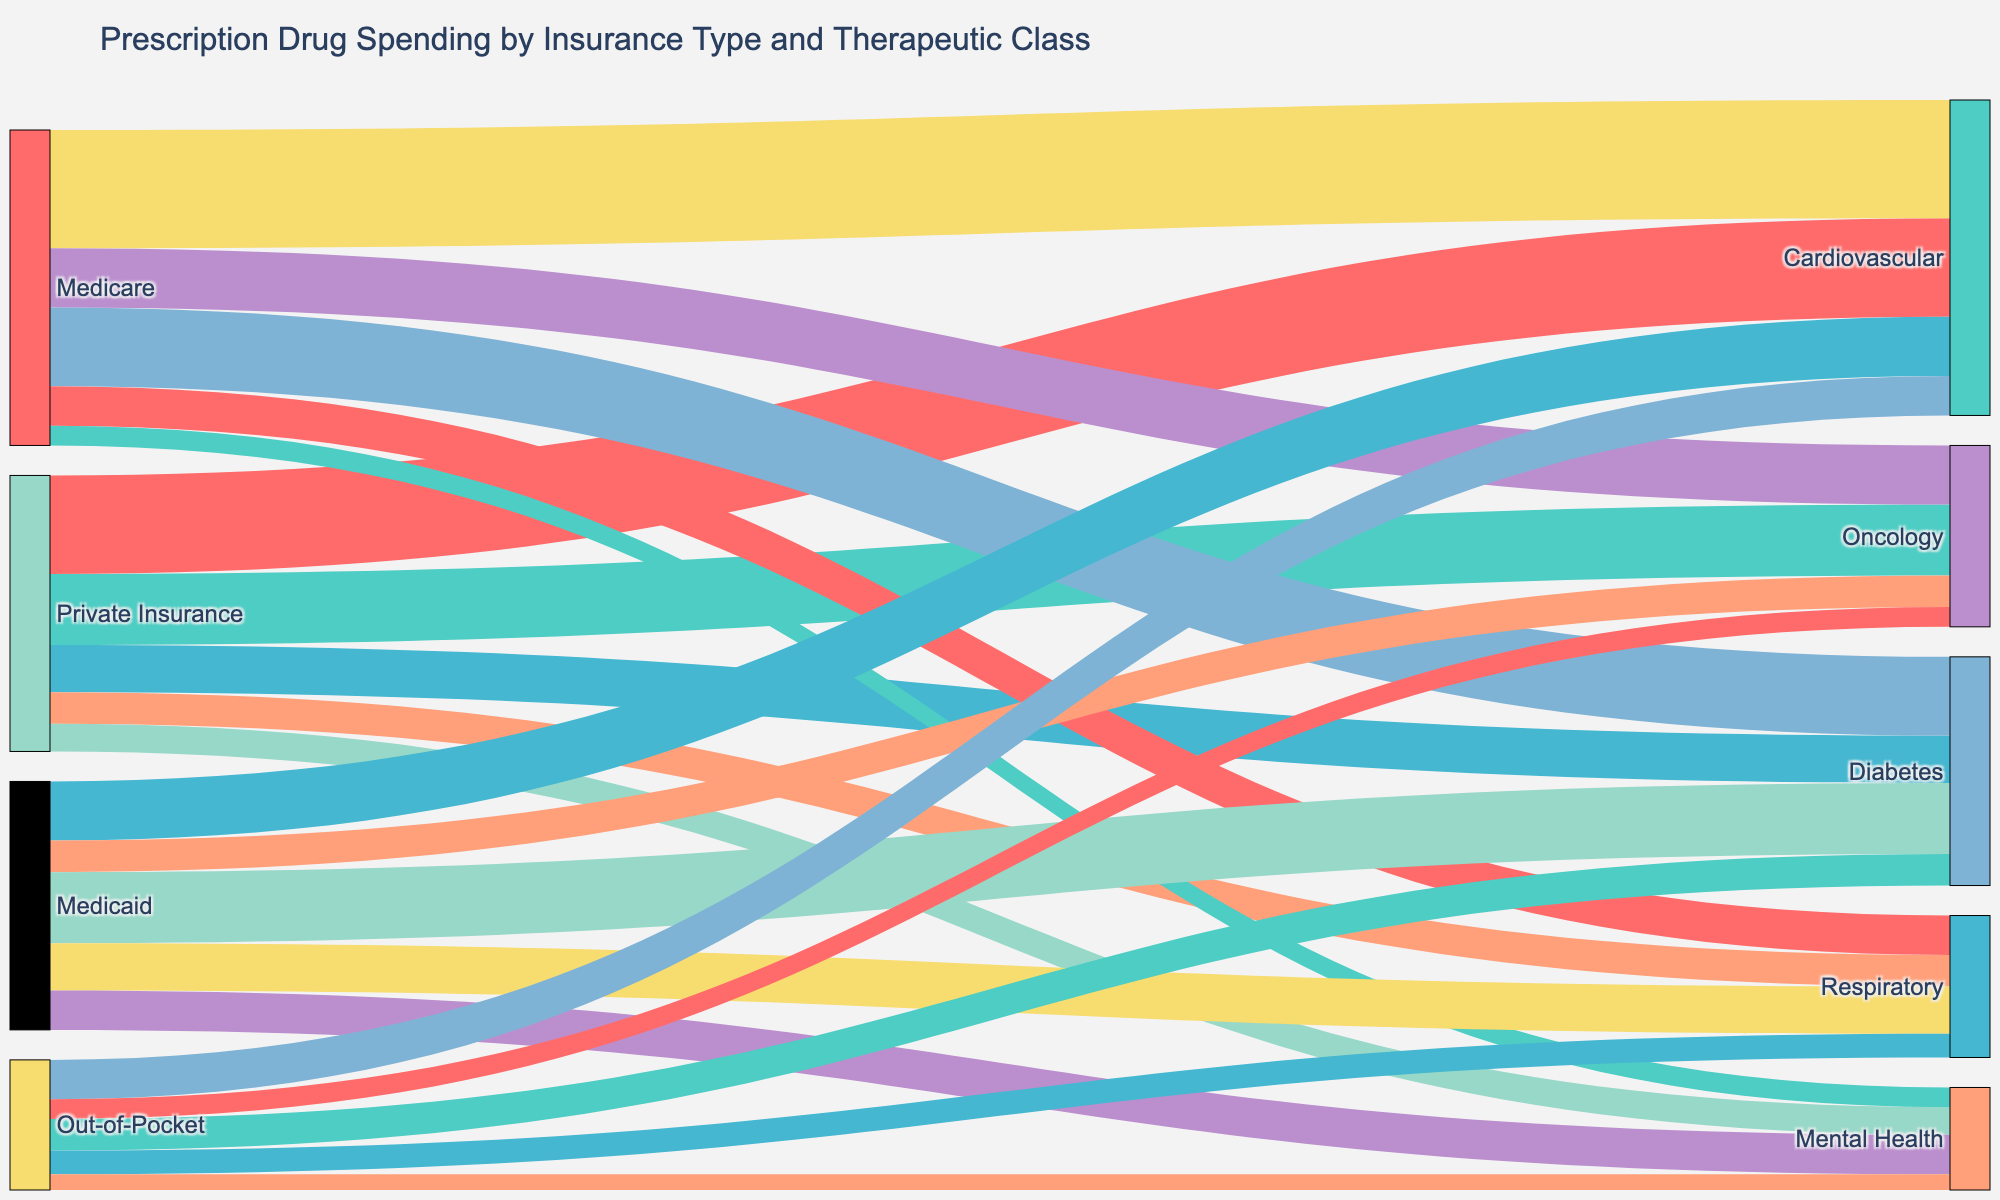What is the title of the Sankey diagram? The title is located at the top of the diagram. It gives a short description of what the figure represents.
Answer: Prescription Drug Spending by Insurance Type and Therapeutic Class Which insurance type has the highest spending on Cardiovascular drugs? Look at the links stemming from different insurance types to the Cardiovascular target. The link with the highest value indicates the maximum spending.
Answer: Medicare How much is the total spending on Oncology drugs across all insurance types? Sum the values of all links pointing to the Oncology target. Add values from Private Insurance (18), Medicare (15), Medicaid (8), and Out-of-Pocket (5).
Answer: 46 Compare the spending on Diabetes drugs between Private Insurance and Medicaid. Which is higher? Look at the links from Private Insurance and Medicaid to Diabetes. Compare the values from each insurance type to determine which is higher.
Answer: Medicaid What is the combined spending on Respiratory drugs by Medicare and Medicaid? Locate the links from Medicare and Medicaid to Respiratory. Add their values together, which are 10 (Medicare) and 12 (Medicaid).
Answer: 22 Which therapeutic class has the least spending from Out-of-Pocket expenses? Identify all links originating from Out-of-Pocket and find the one with the smallest value. The options are Cardiovascular (10), Oncology (5), Diabetes (8), Respiratory (6), and Mental Health (4).
Answer: Mental Health What percentage of Private Insurance spending does Cardiovascular drugs take up? Find the total Private Insurance spending by adding all its links: Cardiovascular (25), Oncology (18), Diabetes (12), Respiratory (8), and Mental Health (7). Then, calculate the percentage for Cardiovascular (25 / (25+18+12+8+7) * 100).
Answer: 35.21% By how much does Medicare's spending on Cardiovascular drugs exceed the combined spending from Private Insurance and Medicaid? Calculate Medicare's Cardiovascular spending (30). Then sum up the spending from Private Insurance (25) and Medicaid (15). Find the difference (30 - (25+15)).
Answer: -10 Is the spending on Mental Health drugs higher for Medicaid or Medicare? Compare the links from Medicaid and Medicare to Mental Health. The values are 10 (Medicaid) and 5 (Medicare).
Answer: Medicaid 